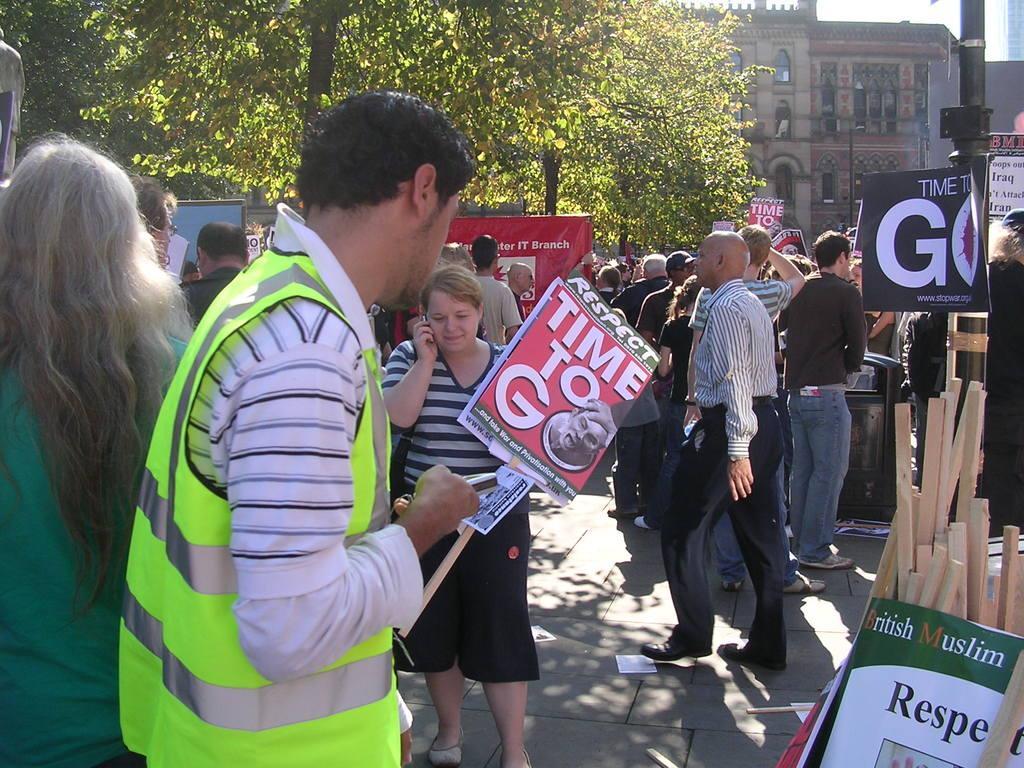In one or two sentences, can you explain what this image depicts? In this image there are trees towards the top of the image, there are buildings, there is a pole towards the right of the image, there are boards towards the right of the image, there is text on the boards, there are wooden objects towards the right of the image, there are a group of persons, they are holding an object, there is ground towards the bottom of the image, there are objects on the ground. 